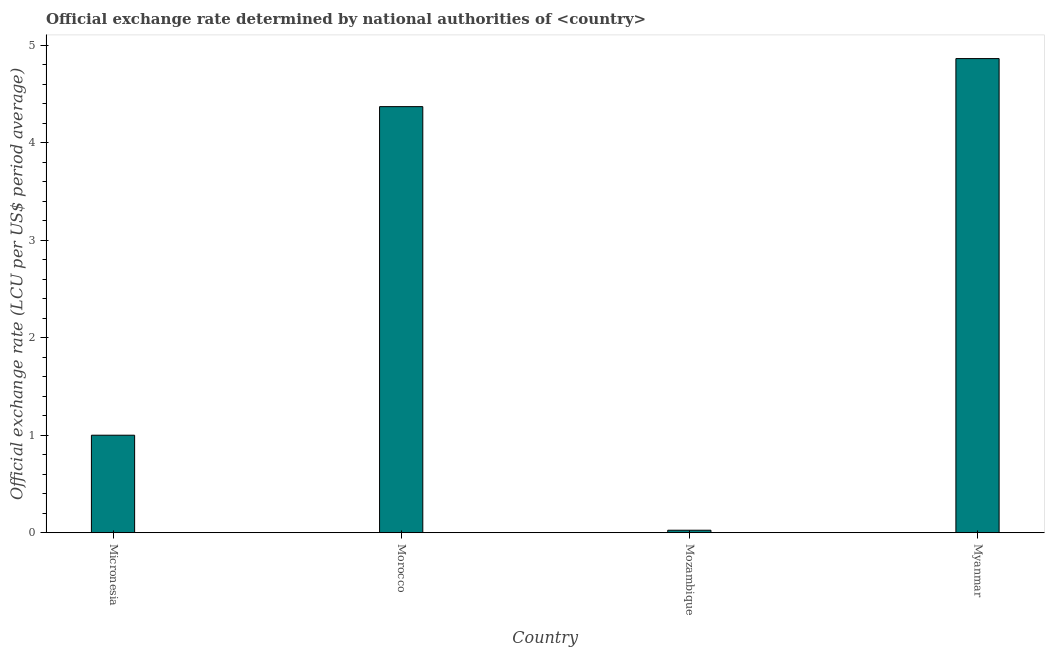Does the graph contain any zero values?
Your response must be concise. No. Does the graph contain grids?
Make the answer very short. No. What is the title of the graph?
Give a very brief answer. Official exchange rate determined by national authorities of <country>. What is the label or title of the Y-axis?
Your answer should be very brief. Official exchange rate (LCU per US$ period average). What is the official exchange rate in Mozambique?
Ensure brevity in your answer.  0.03. Across all countries, what is the maximum official exchange rate?
Give a very brief answer. 4.86. Across all countries, what is the minimum official exchange rate?
Offer a very short reply. 0.03. In which country was the official exchange rate maximum?
Your response must be concise. Myanmar. In which country was the official exchange rate minimum?
Give a very brief answer. Mozambique. What is the sum of the official exchange rate?
Your response must be concise. 10.26. What is the difference between the official exchange rate in Micronesia and Morocco?
Your answer should be very brief. -3.37. What is the average official exchange rate per country?
Your answer should be very brief. 2.56. What is the median official exchange rate?
Provide a short and direct response. 2.68. In how many countries, is the official exchange rate greater than 3.8 ?
Offer a very short reply. 2. What is the ratio of the official exchange rate in Micronesia to that in Myanmar?
Your answer should be very brief. 0.21. Is the official exchange rate in Micronesia less than that in Morocco?
Offer a terse response. Yes. What is the difference between the highest and the second highest official exchange rate?
Your answer should be compact. 0.49. Is the sum of the official exchange rate in Micronesia and Morocco greater than the maximum official exchange rate across all countries?
Offer a terse response. Yes. What is the difference between the highest and the lowest official exchange rate?
Offer a very short reply. 4.84. How many bars are there?
Your response must be concise. 4. Are all the bars in the graph horizontal?
Make the answer very short. No. How many countries are there in the graph?
Make the answer very short. 4. What is the Official exchange rate (LCU per US$ period average) in Micronesia?
Your answer should be very brief. 1. What is the Official exchange rate (LCU per US$ period average) of Morocco?
Give a very brief answer. 4.37. What is the Official exchange rate (LCU per US$ period average) in Mozambique?
Make the answer very short. 0.03. What is the Official exchange rate (LCU per US$ period average) in Myanmar?
Make the answer very short. 4.86. What is the difference between the Official exchange rate (LCU per US$ period average) in Micronesia and Morocco?
Ensure brevity in your answer.  -3.37. What is the difference between the Official exchange rate (LCU per US$ period average) in Micronesia and Mozambique?
Give a very brief answer. 0.97. What is the difference between the Official exchange rate (LCU per US$ period average) in Micronesia and Myanmar?
Offer a terse response. -3.86. What is the difference between the Official exchange rate (LCU per US$ period average) in Morocco and Mozambique?
Make the answer very short. 4.34. What is the difference between the Official exchange rate (LCU per US$ period average) in Morocco and Myanmar?
Offer a very short reply. -0.49. What is the difference between the Official exchange rate (LCU per US$ period average) in Mozambique and Myanmar?
Provide a short and direct response. -4.84. What is the ratio of the Official exchange rate (LCU per US$ period average) in Micronesia to that in Morocco?
Offer a very short reply. 0.23. What is the ratio of the Official exchange rate (LCU per US$ period average) in Micronesia to that in Mozambique?
Your answer should be compact. 39.36. What is the ratio of the Official exchange rate (LCU per US$ period average) in Micronesia to that in Myanmar?
Your answer should be compact. 0.21. What is the ratio of the Official exchange rate (LCU per US$ period average) in Morocco to that in Mozambique?
Offer a very short reply. 171.98. What is the ratio of the Official exchange rate (LCU per US$ period average) in Morocco to that in Myanmar?
Ensure brevity in your answer.  0.9. What is the ratio of the Official exchange rate (LCU per US$ period average) in Mozambique to that in Myanmar?
Give a very brief answer. 0.01. 